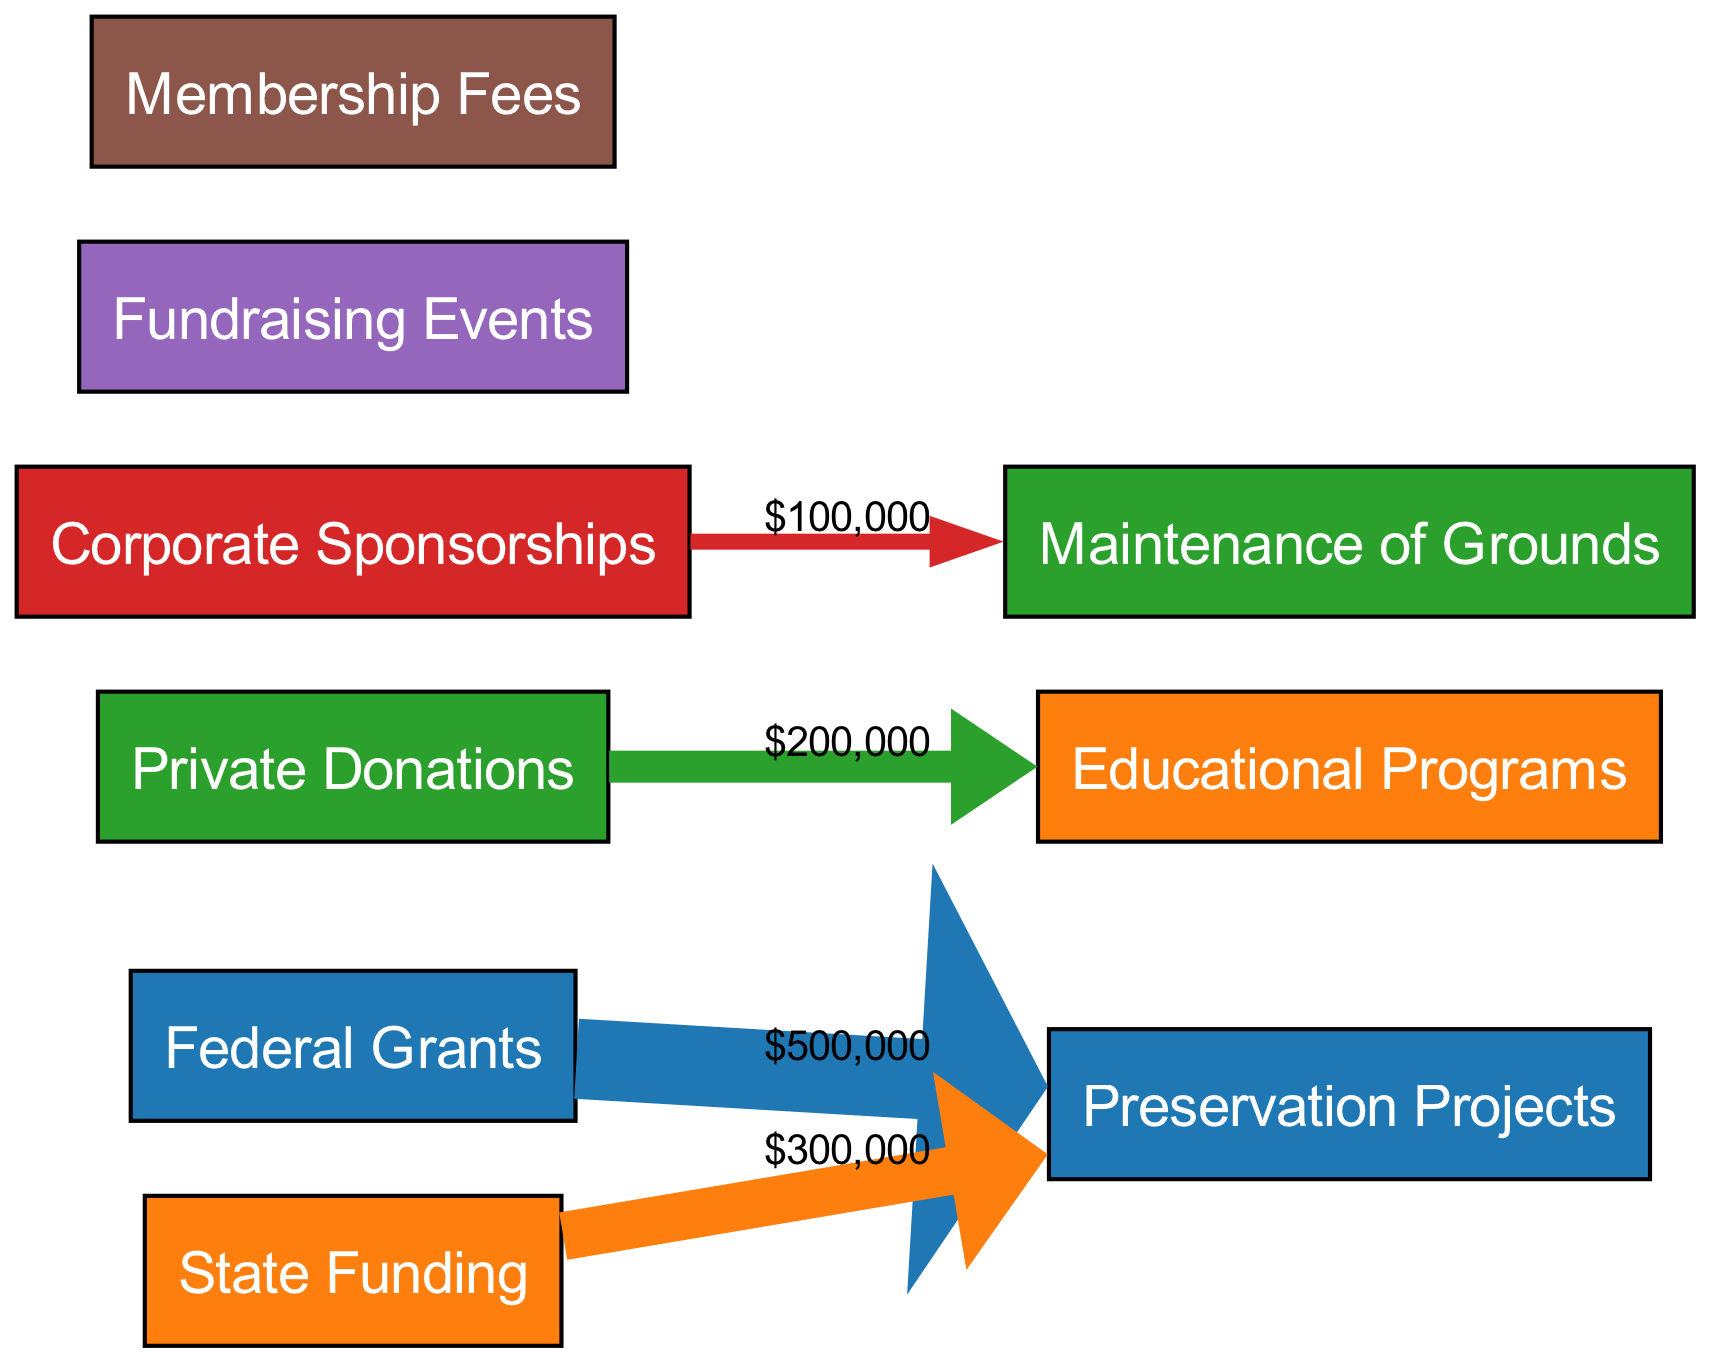What is the largest source of funding? The funding sources are labeled and their amounts are shown, with the largest being "Federal Grants" amounting to 500,000.
Answer: Federal Grants How much funding comes from Corporate Sponsorships? The diagram specifies the amount for "Corporate Sponsorships," which is directly labeled as 150,000.
Answer: 150,000 What is the total amount allocated for Preservation Projects? The diagram shows "Preservation Projects" with an amount of 800,000, which is directly indicated in the node.
Answer: 800,000 Which source contributes the least amount? Among the funding sources, "Membership Fees" has the smallest amount listed at 50,000, which can be seen directly in the diagram.
Answer: Membership Fees How many total funding sources are represented in the diagram? By counting the boxes labeled under "sources," there are 6 funding sources total displayed.
Answer: 6 What is the total amount of funding allocated for Educational Programs? The diagram specifically indicates that "Educational Programs" is allocated 200,000, which is stated clearly in its respective node.
Answer: 200,000 Which funding source contributes the most to Maintenance of Grounds? Since "Maintenance of Grounds" is part of the flows, we track the contributions, and find that the maximum contribution comes from "Federal Grants" since it is the largest source overall.
Answer: Federal Grants What percentage of total funding comes from Private Donations? To find this, we note that "Private Donations" is 200,000, and the total amount of funding sources is 1,500,000. The percentage is calculated as (200,000 / 1,500,000) * 100 = 13.33%.
Answer: 13.33% How are the funds distributed between Preservation Projects and Educational Programs? The amounts for both projects are given: 800,000 for Preservation Projects and 200,000 for Educational Programs. The distribution shows a significant emphasis on Preservation Projects over the educational component.
Answer: 800,000 for Preservation Projects; 200,000 for Educational Programs 